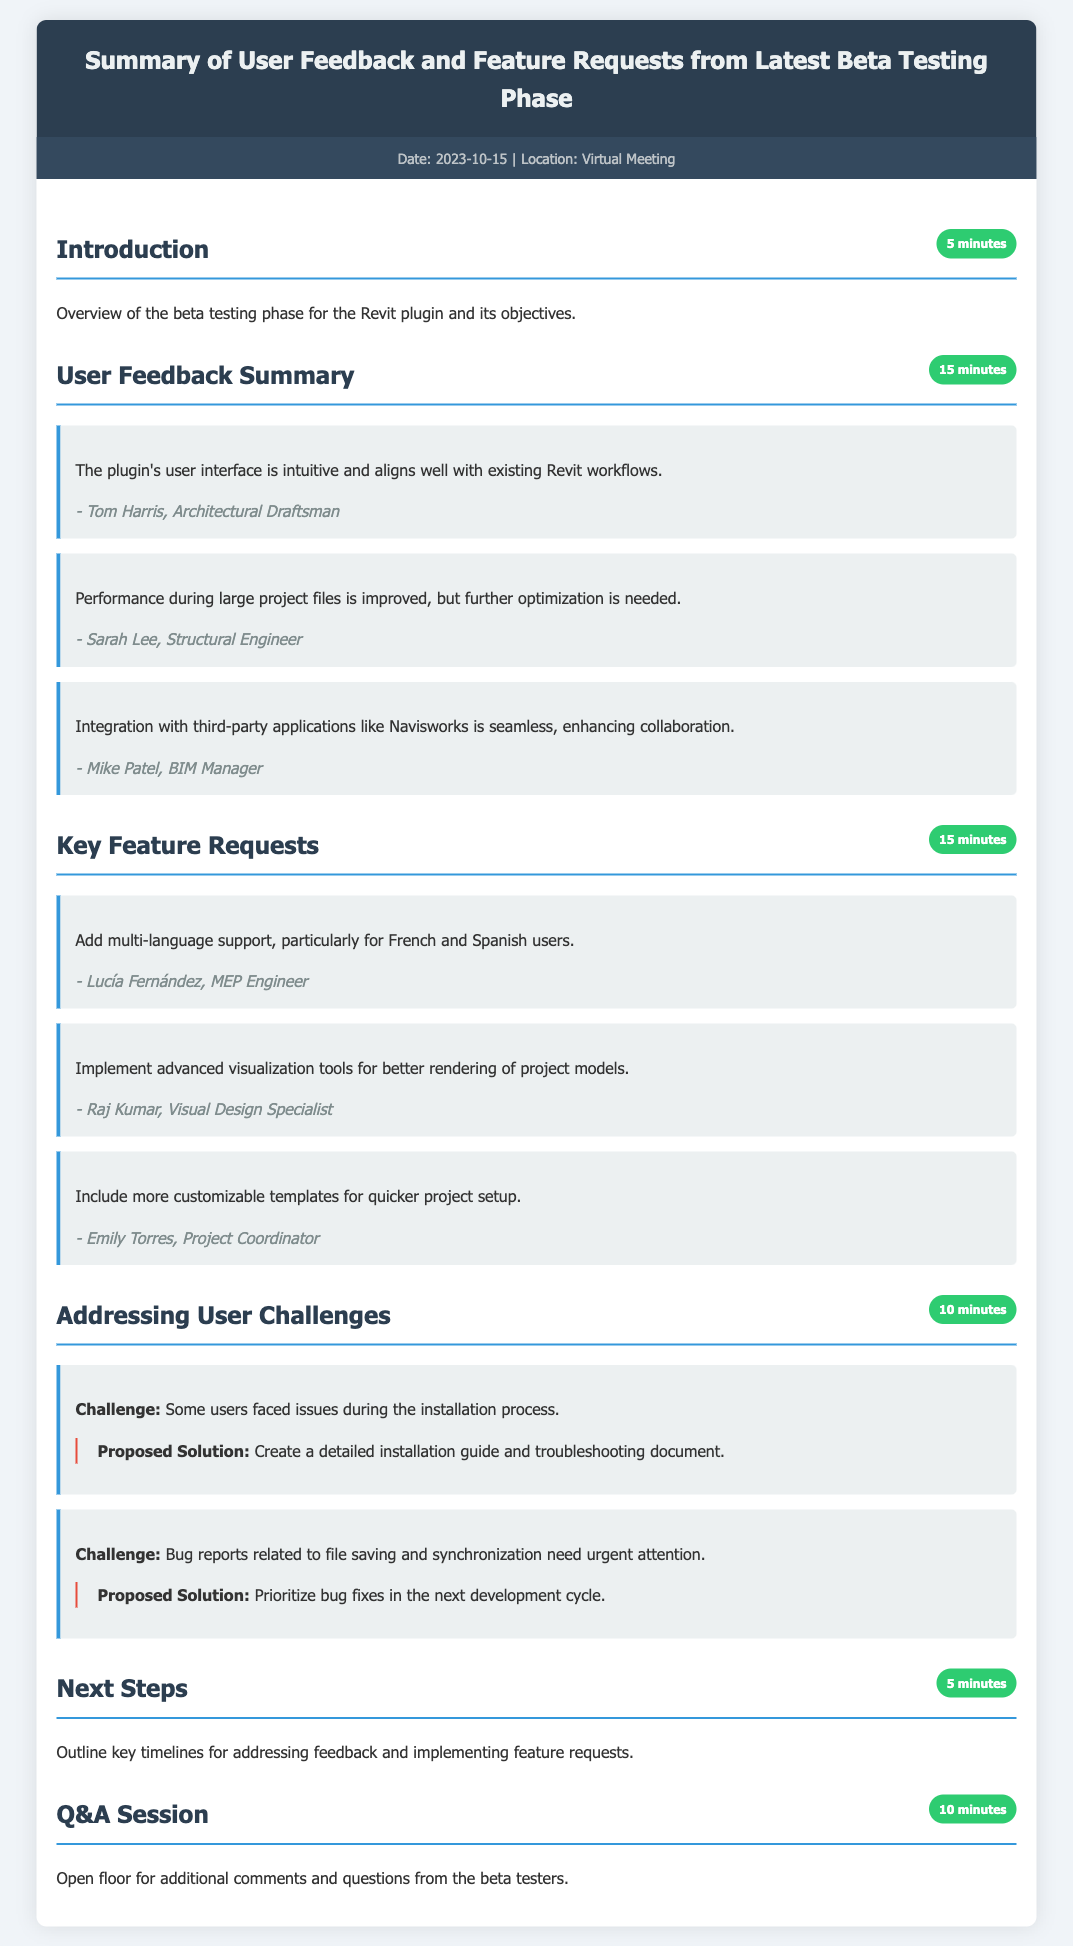What is the date of the meeting? The date of the meeting is explicitly stated in the meta-info section of the document.
Answer: 2023-10-15 What section discusses user interface feedback? The section titled "User Feedback Summary" contains comments related to the user interface.
Answer: User Feedback Summary Who requested multi-language support? The name of the user requesting this feature is found in the key feature requests section.
Answer: Lucía Fernández How long is the Q&A session? The duration for the Q&A session is identified in the document under the respective section heading.
Answer: 10 minutes What challenge relates to installation? The specific challenge about installation is mentioned in the challenges section of the document.
Answer: Issues during the installation process Which user highlighted the need for advanced visualization tools? The document attributes this request to a specific user in the feature requests section.
Answer: Raj Kumar What is the proposed solution for issues with file saving? The proposed solution to this challenge is detailed under the challenges section of the document.
Answer: Prioritize bug fixes in the next development cycle How many minutes are allocated for the introduction? The duration for the introduction is stated alongside the section title.
Answer: 5 minutes 